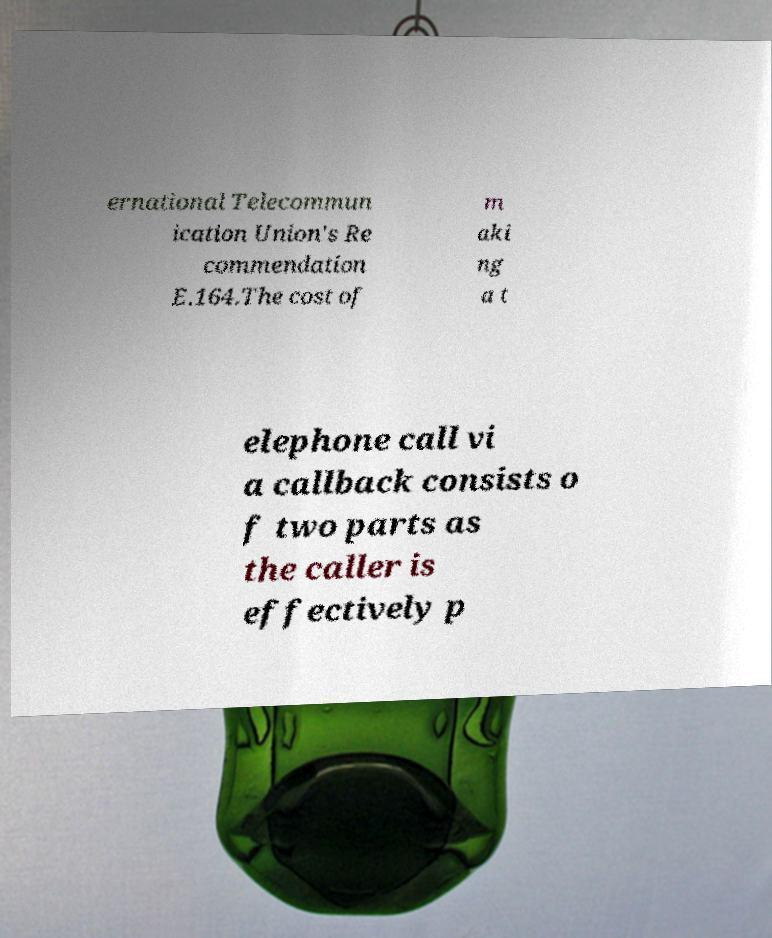Please identify and transcribe the text found in this image. ernational Telecommun ication Union's Re commendation E.164.The cost of m aki ng a t elephone call vi a callback consists o f two parts as the caller is effectively p 